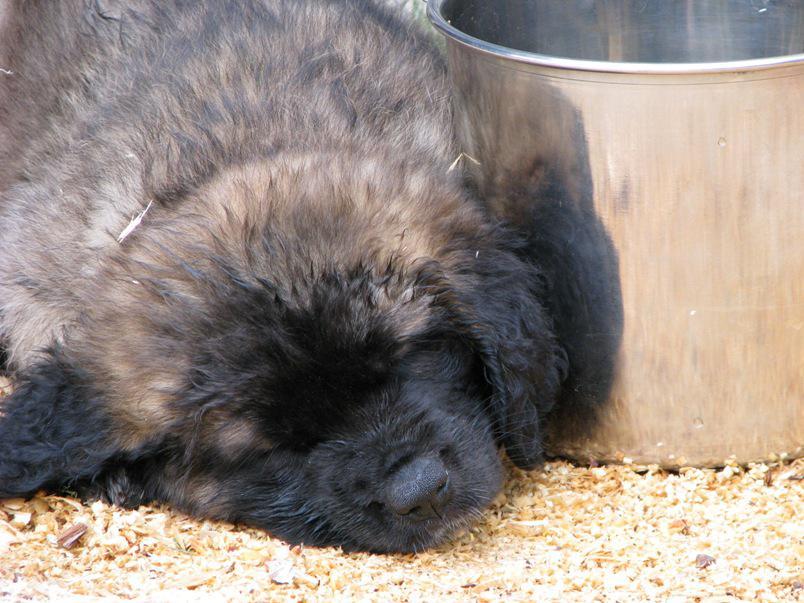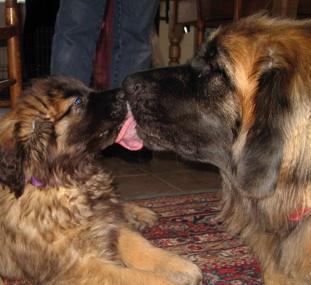The first image is the image on the left, the second image is the image on the right. Evaluate the accuracy of this statement regarding the images: "There is a single brown dog sleeping alone in the image on the right.". Is it true? Answer yes or no. No. The first image is the image on the left, the second image is the image on the right. For the images shown, is this caption "A dog's pink tongue is visible in one image." true? Answer yes or no. Yes. 